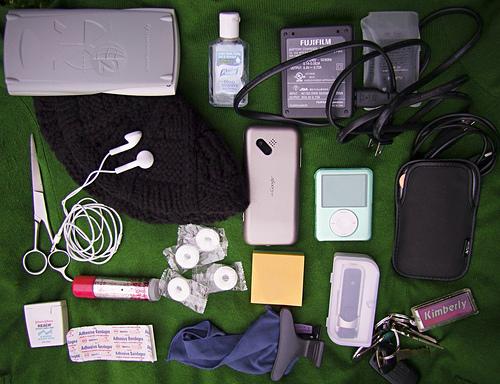What name is on the key chain?
Keep it brief. Kimberly. What color is the music player?
Give a very brief answer. Blue. What color are the earbuds?
Write a very short answer. White. Is this a first aid kit?
Quick response, please. No. 